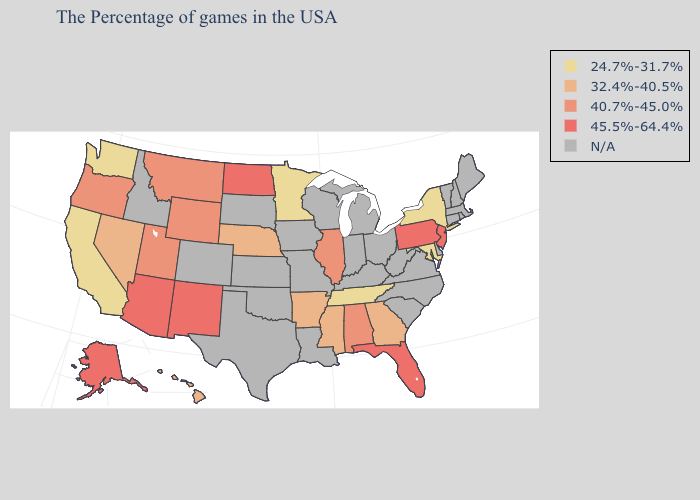Does the first symbol in the legend represent the smallest category?
Give a very brief answer. Yes. How many symbols are there in the legend?
Quick response, please. 5. Does Wyoming have the lowest value in the USA?
Be succinct. No. Name the states that have a value in the range N/A?
Give a very brief answer. Maine, Massachusetts, Rhode Island, New Hampshire, Vermont, Connecticut, Delaware, Virginia, North Carolina, South Carolina, West Virginia, Ohio, Michigan, Kentucky, Indiana, Wisconsin, Louisiana, Missouri, Iowa, Kansas, Oklahoma, Texas, South Dakota, Colorado, Idaho. Name the states that have a value in the range 40.7%-45.0%?
Concise answer only. Alabama, Illinois, Wyoming, Utah, Montana, Oregon. Name the states that have a value in the range N/A?
Be succinct. Maine, Massachusetts, Rhode Island, New Hampshire, Vermont, Connecticut, Delaware, Virginia, North Carolina, South Carolina, West Virginia, Ohio, Michigan, Kentucky, Indiana, Wisconsin, Louisiana, Missouri, Iowa, Kansas, Oklahoma, Texas, South Dakota, Colorado, Idaho. Name the states that have a value in the range 24.7%-31.7%?
Give a very brief answer. New York, Maryland, Tennessee, Minnesota, California, Washington. What is the highest value in the MidWest ?
Write a very short answer. 45.5%-64.4%. What is the value of Wisconsin?
Keep it brief. N/A. Does the first symbol in the legend represent the smallest category?
Concise answer only. Yes. Does Washington have the lowest value in the West?
Keep it brief. Yes. What is the highest value in the West ?
Give a very brief answer. 45.5%-64.4%. What is the value of New Mexico?
Concise answer only. 45.5%-64.4%. 